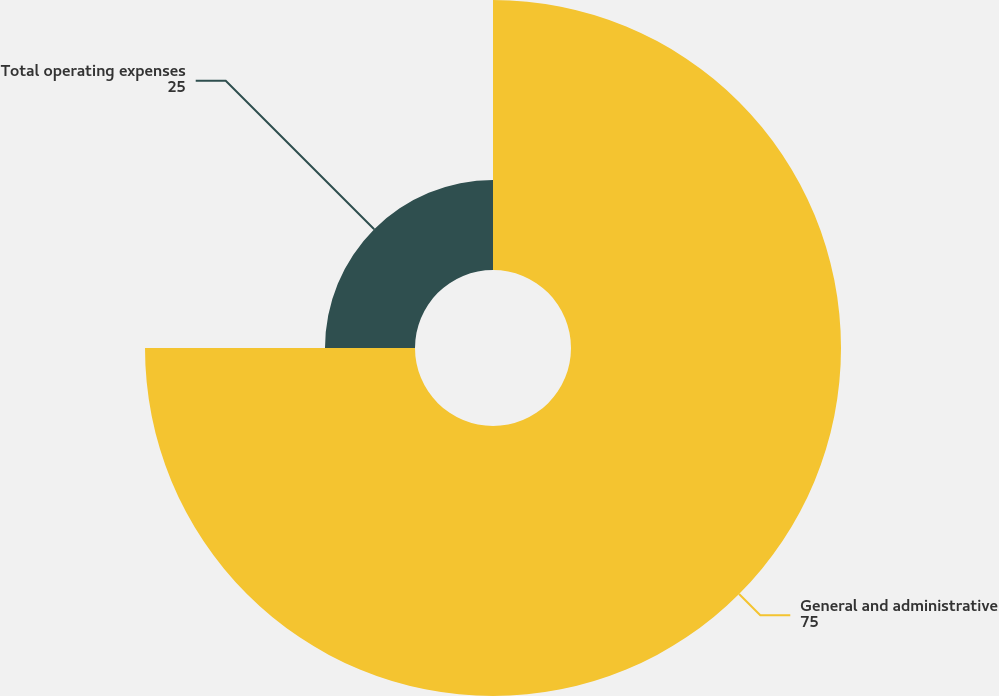<chart> <loc_0><loc_0><loc_500><loc_500><pie_chart><fcel>General and administrative<fcel>Total operating expenses<nl><fcel>75.0%<fcel>25.0%<nl></chart> 